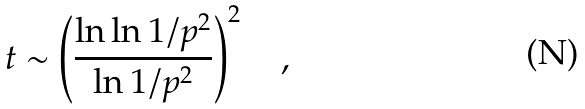Convert formula to latex. <formula><loc_0><loc_0><loc_500><loc_500>t \sim \left ( \frac { \ln \ln 1 / { p } ^ { 2 } } { \ln 1 / { p } ^ { 2 } } \right ) ^ { 2 } \quad ,</formula> 